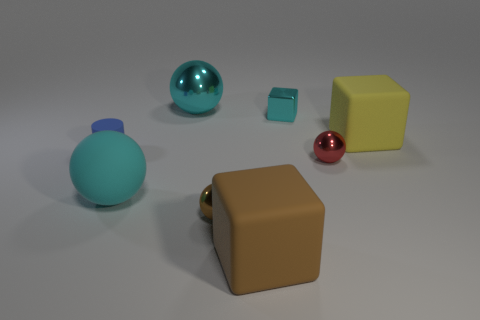What is the color of the large shiny object that is the same shape as the small red shiny thing?
Provide a succinct answer. Cyan. Is there anything else that has the same shape as the blue object?
Offer a terse response. No. How many balls are tiny shiny objects or big metallic things?
Keep it short and to the point. 3. There is a tiny cyan shiny object; what shape is it?
Your answer should be compact. Cube. There is a cyan cube; are there any small blue things right of it?
Make the answer very short. No. Is the small brown object made of the same material as the brown object on the right side of the brown metallic object?
Keep it short and to the point. No. Is the shape of the small thing that is in front of the large rubber ball the same as  the small matte thing?
Offer a very short reply. No. How many yellow things are made of the same material as the brown ball?
Your answer should be compact. 0. How many objects are either big cyan balls that are behind the small cyan metal block or metallic blocks?
Offer a very short reply. 2. What size is the brown metallic ball?
Offer a terse response. Small. 